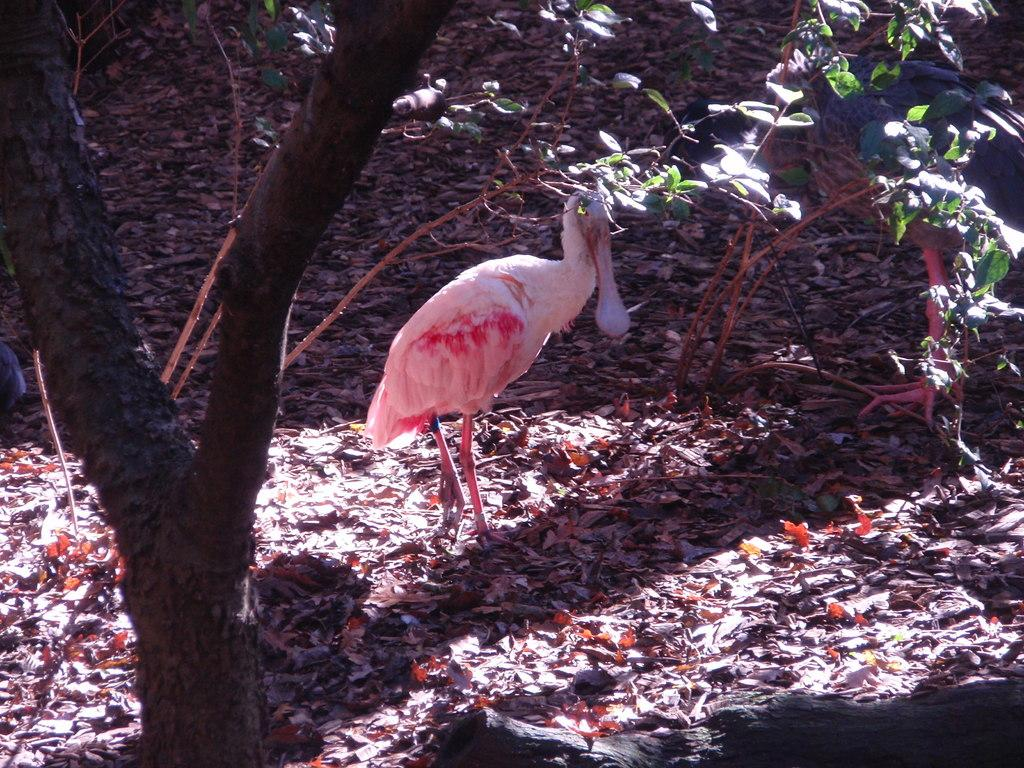What type of animal is in the image? There is a bird in the image. What colors can be seen on the bird? The bird has white and pink colors. What type of vegetation is present in the image? There are trees in the image. What part of the trees can be seen in the image? There are leaves in the image. Can you hear the sound of the cobweb in the image? There is no cobweb present in the image, and therefore no sound can be heard from it. 